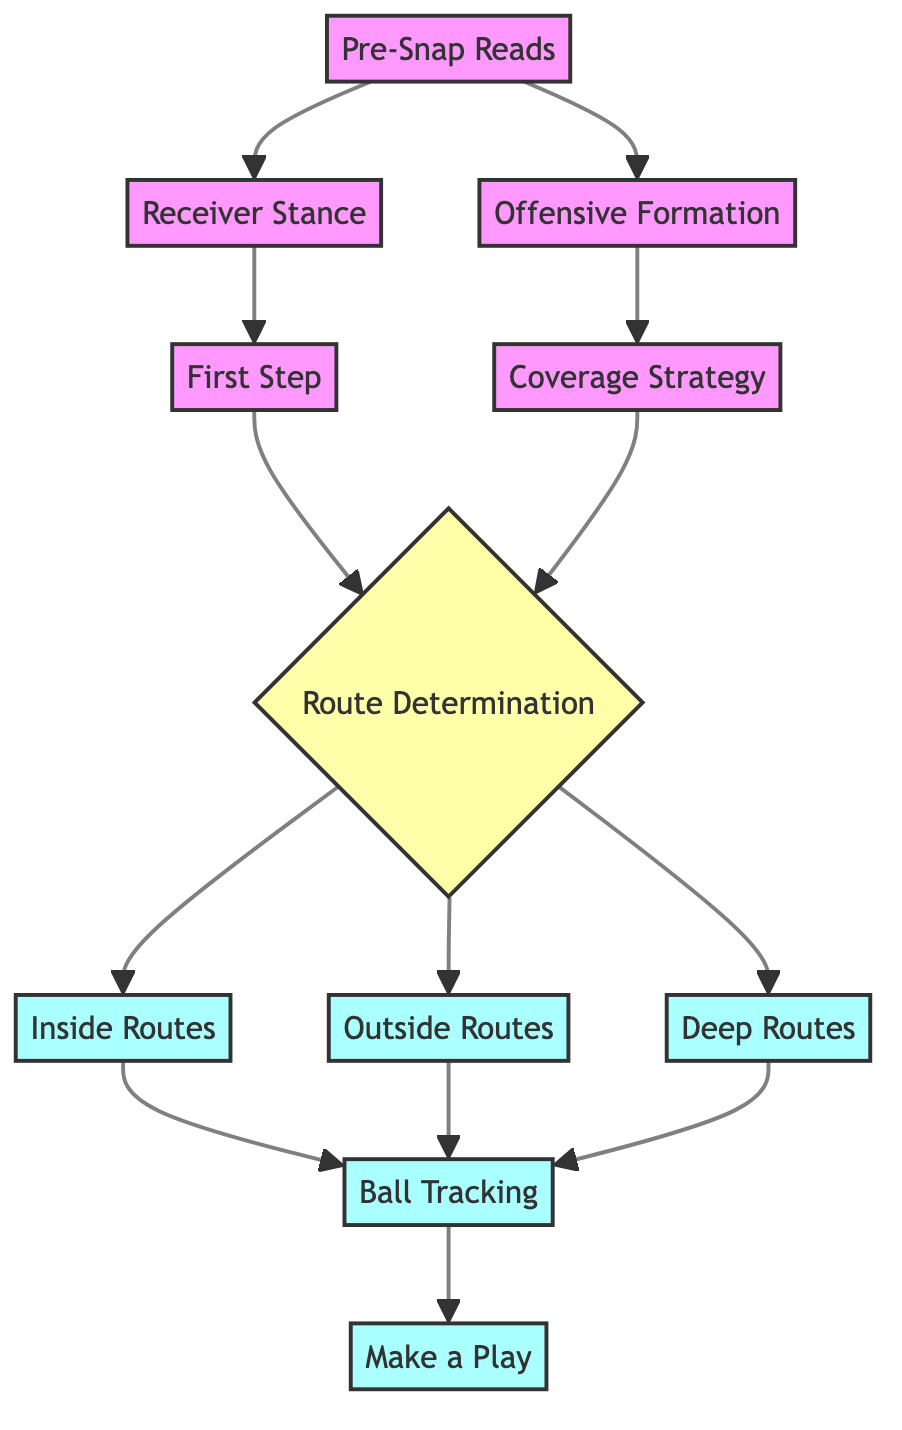What is the first step in the process? The first node in the flow chart is "Pre-Snap Reads," which indicates that this is the initial step in the instruction guide.
Answer: Pre-Snap Reads How many nodes are there in the diagram? By counting all the unique steps provided in the flowchart, there are a total of 11 nodes including the various actions and decisions.
Answer: 11 What node follows "Coverage Strategy"? Following "Coverage Strategy," according to the diagram structure, the next step is "Route Determination."
Answer: Route Determination Which routes require you to maintain inside leverage? According to the paths defined in the flow chart, routes that break inside, such as slants and ins, require maintaining inside leverage.
Answer: Inside Routes What type of routes should you track for explosive plays? The flow chart indicates that you should track deep routes like go routes and posts to prevent an explosive play.
Answer: Deep Routes What is the final action to take in the process? The last action listed in the flow chart is "Make a Play," which indicates the conclusion of the instruction process.
Answer: Make a Play If you need to maintain outside leverage, which route category are you dealing with? The flow chart states that outside leverage is required for routes breaking outside, such as outs and fades.
Answer: Outside Routes What determines the coverage strategy between man-to-man or zone? The coverage strategy is decided based on the offensive alignment as indicated in the "Coverage Strategy" node followed by connectivity to "Route Determination."
Answer: Offensive Alignment How many distinct paths branch out from the "Route Determination" node? The "Route Determination" node branches into three distinct paths for categorizing routes: Inside Routes, Outside Routes, and Deep Routes.
Answer: 3 